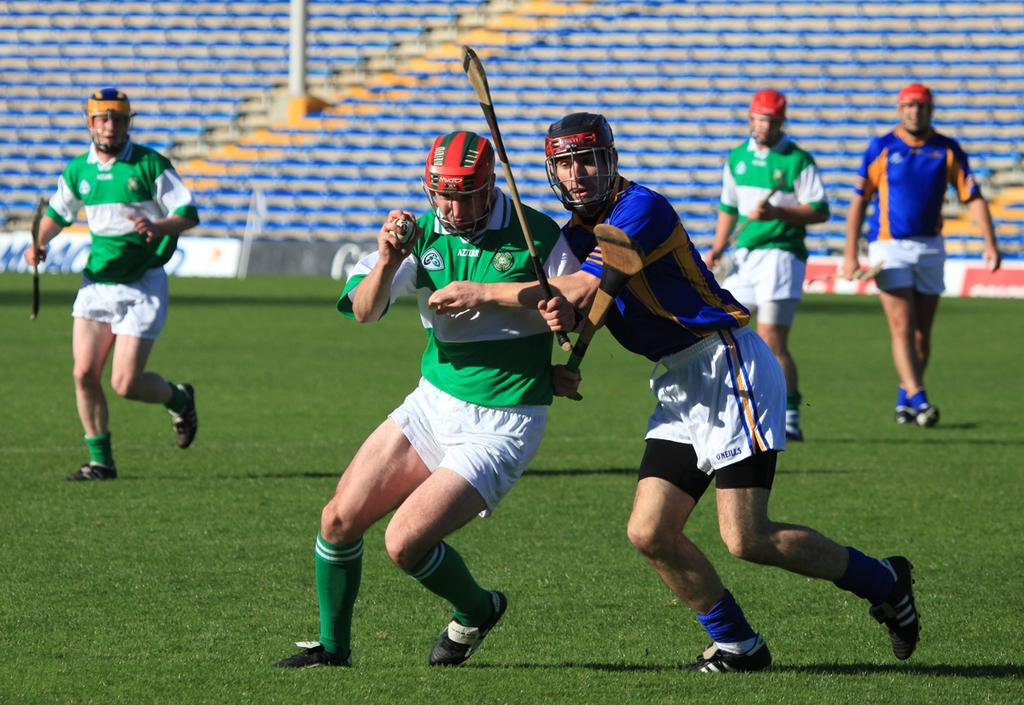What are the men in the image holding? The men in the image are holding an object. What can be seen in the background of the image? There is a playground in the image. What are the boards in the image used for? The boards in the image have text on them. What type of vehicles are present in the image? There are cars in the image. What is the tall, vertical structure in the image? There is a pole towards the top of the image. How many babies are crawling on the playground in the image? There are no babies present in the image; it features men holding an object, a playground, boards with text, cars, and a pole. What direction are the cars moving in the image? The provided facts do not indicate the direction in which the cars are moving. 